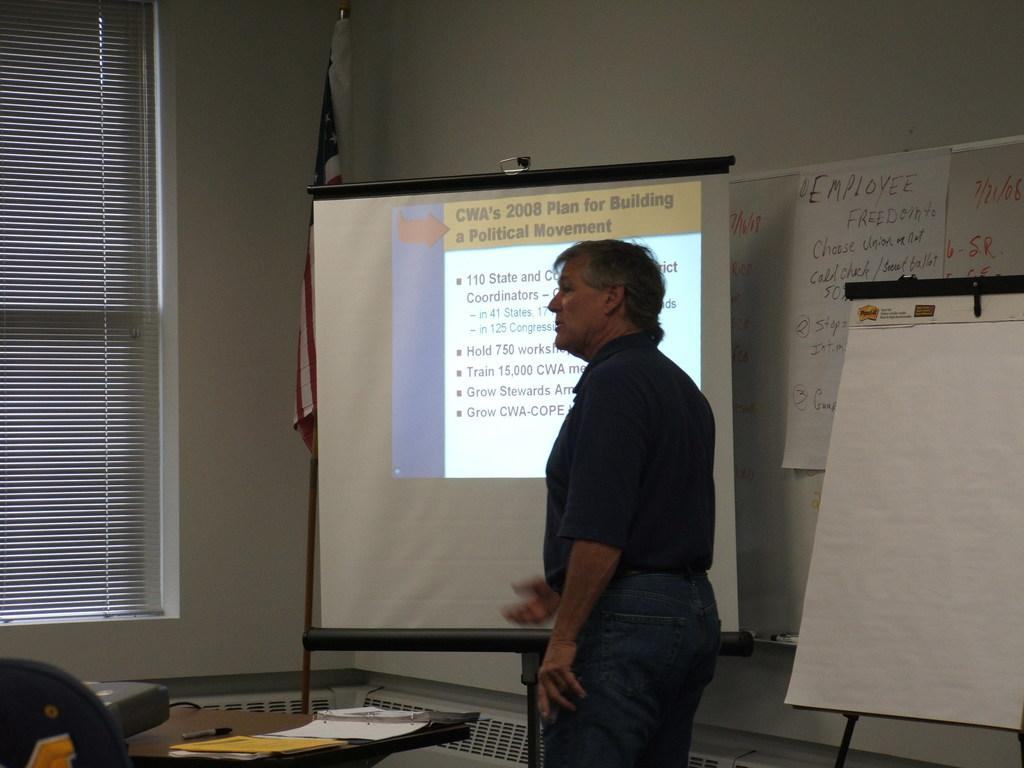Provide a one-sentence caption for the provided image. a man is discussing CNA 2008 Plan to people. 